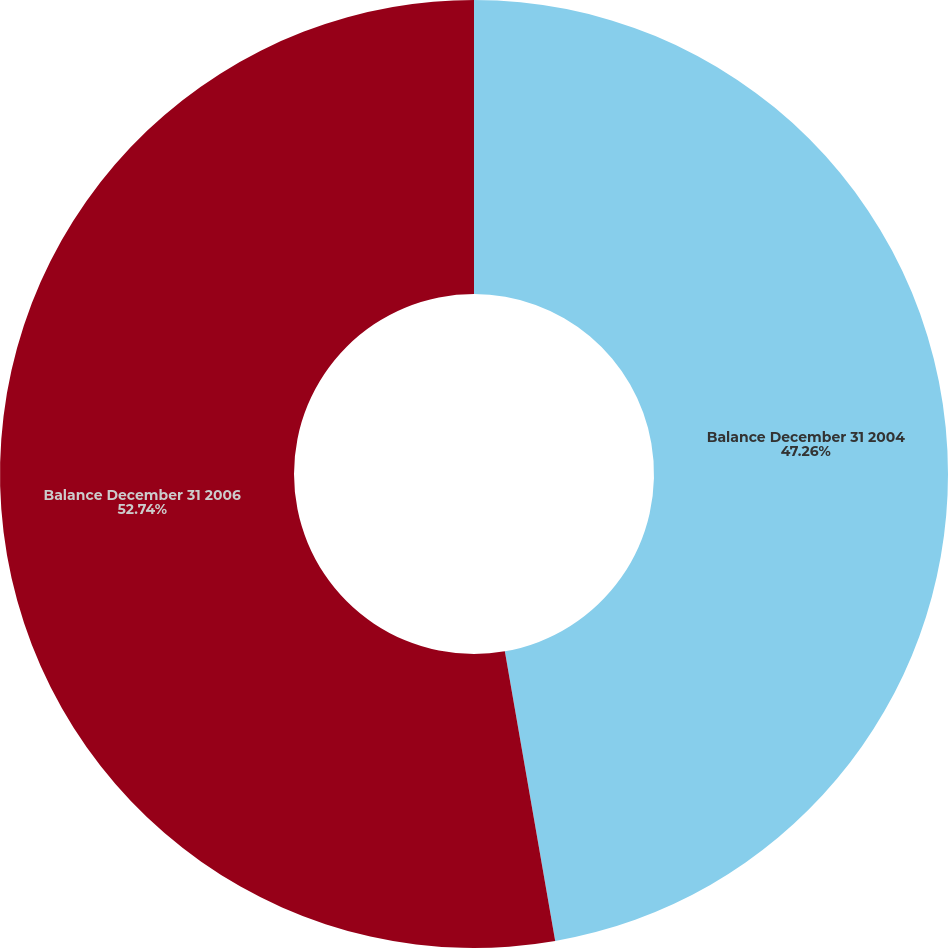Convert chart. <chart><loc_0><loc_0><loc_500><loc_500><pie_chart><fcel>Balance December 31 2004<fcel>Balance December 31 2006<nl><fcel>47.26%<fcel>52.74%<nl></chart> 